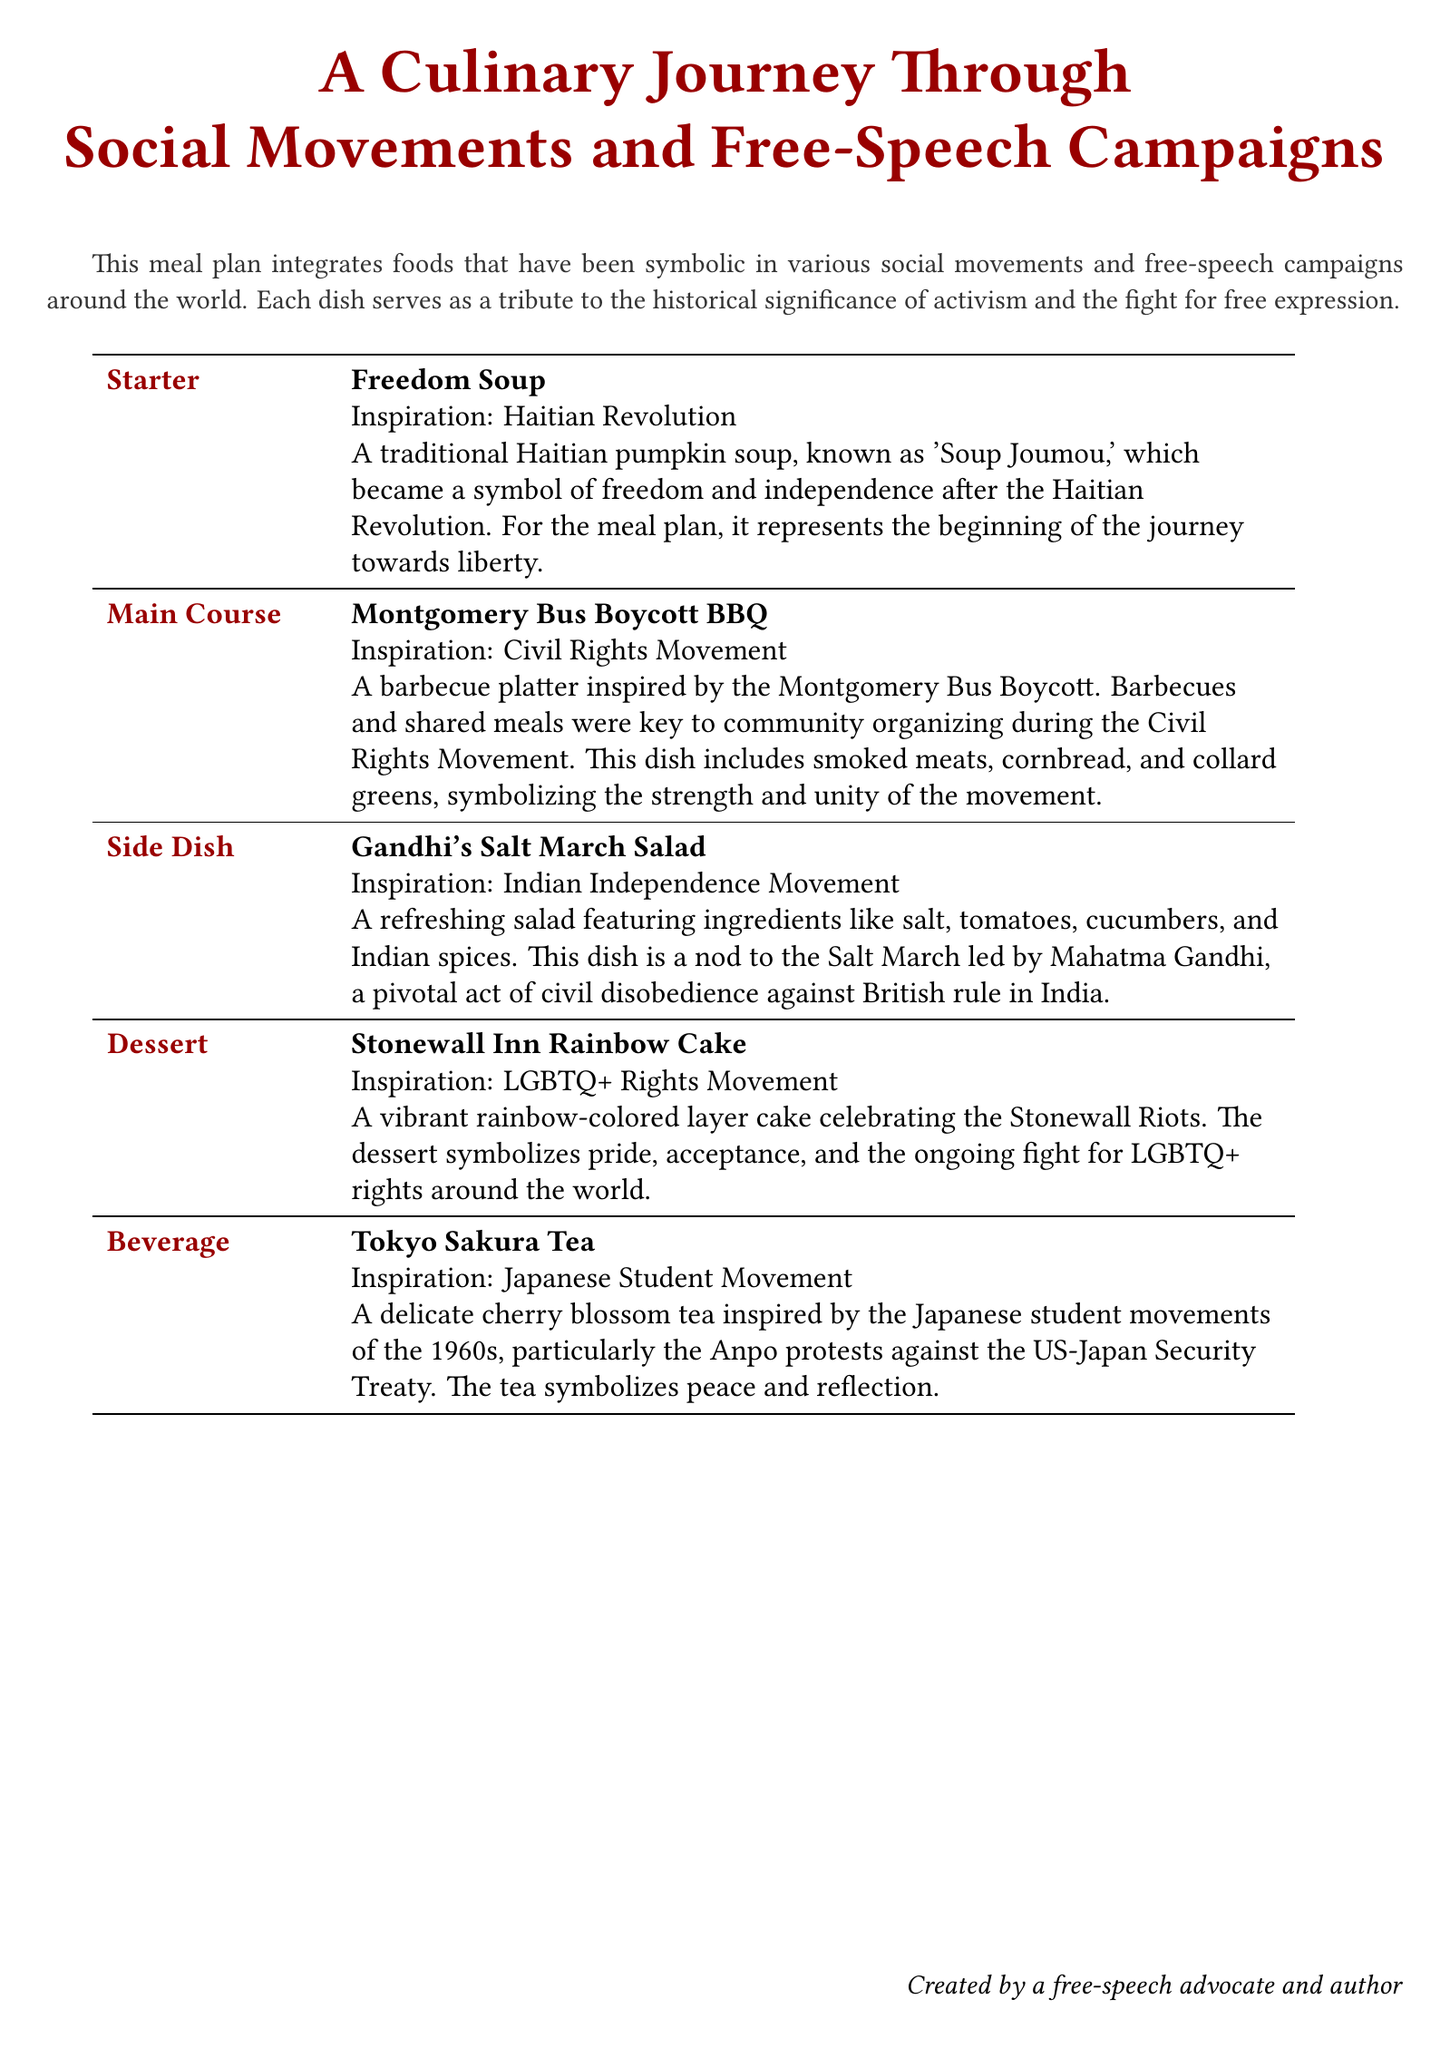What is the name of the starter dish? The starter dish is clearly labeled in the document as "Freedom Soup."
Answer: Freedom Soup What historical event inspired the dessert? The dessert is attributed to a specific movement, which is indicated as inspired by the Stonewall Riots.
Answer: Stonewall Riots Which beverage is linked to the Japanese Student Movement? The beverage section specifies that Tokyo Sakura Tea relates to the Japanese student movements.
Answer: Tokyo Sakura Tea What ingredients are featured in Gandhi's Salt March Salad? The document mentions specific ingredients that make up the salad, including salt, tomatoes, and cucumbers.
Answer: Salt, tomatoes, cucumbers How does the Montgomery Bus Boycott BBQ symbolize the Civil Rights Movement? The document explains that barbecues were vital for community organizing during the movement, emphasizing unity.
Answer: Community organizing and unity What type of cuisine is Freedom Soup categorized under? The document categorizes Freedom Soup as a traditional Haitian dish within the context of the meal plan.
Answer: Haitian What is the significance of the rainbow-colored cake? The dessert has a specific theme tied to a broader social issue, reflecting pride and the fight for rights.
Answer: Pride and LGBTQ+ rights What dish represents the Indian Independence Movement? The meal plan specifically identifies that Gandhi's Salt March Salad reflects this movement.
Answer: Gandhi's Salt March Salad 